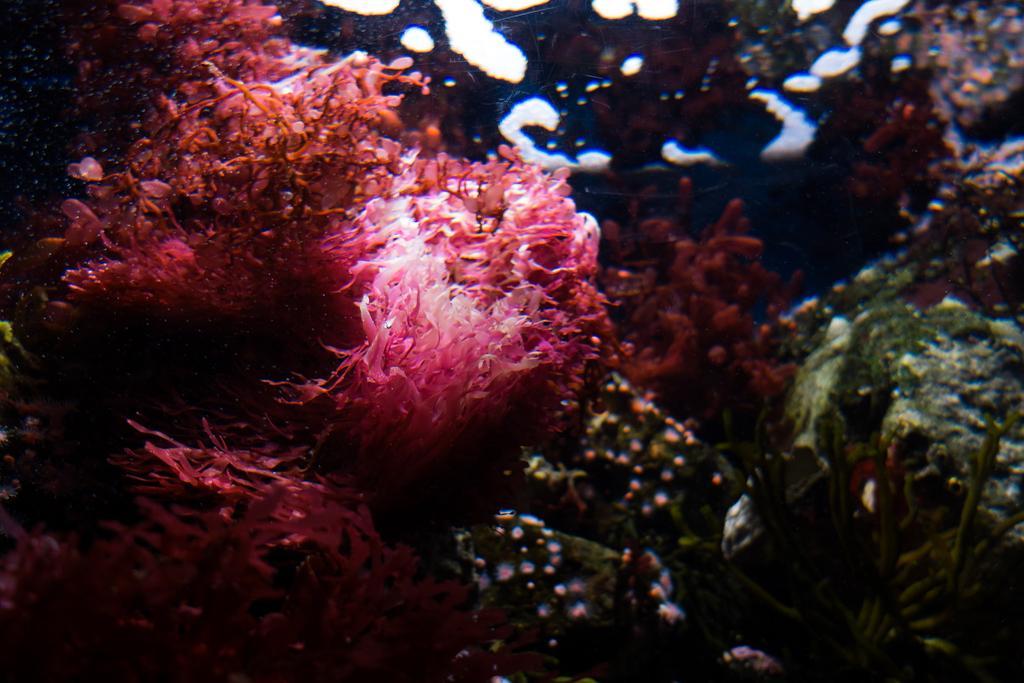Describe this image in one or two sentences. In this image we can see underwater. Also there are corals. 